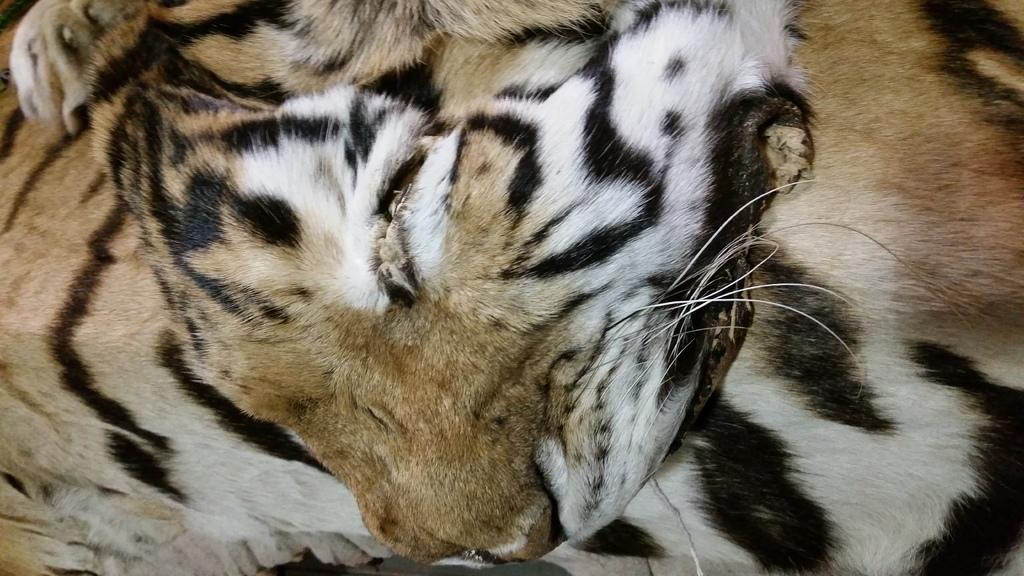What type of animal is in the image? There is a tiger in the image. How many trees are visible in the image? There are no trees visible in the image, as it only features a tiger. What type of rodent can be seen interacting with the tiger in the image? There is no rodent present in the image; it only features a tiger. 